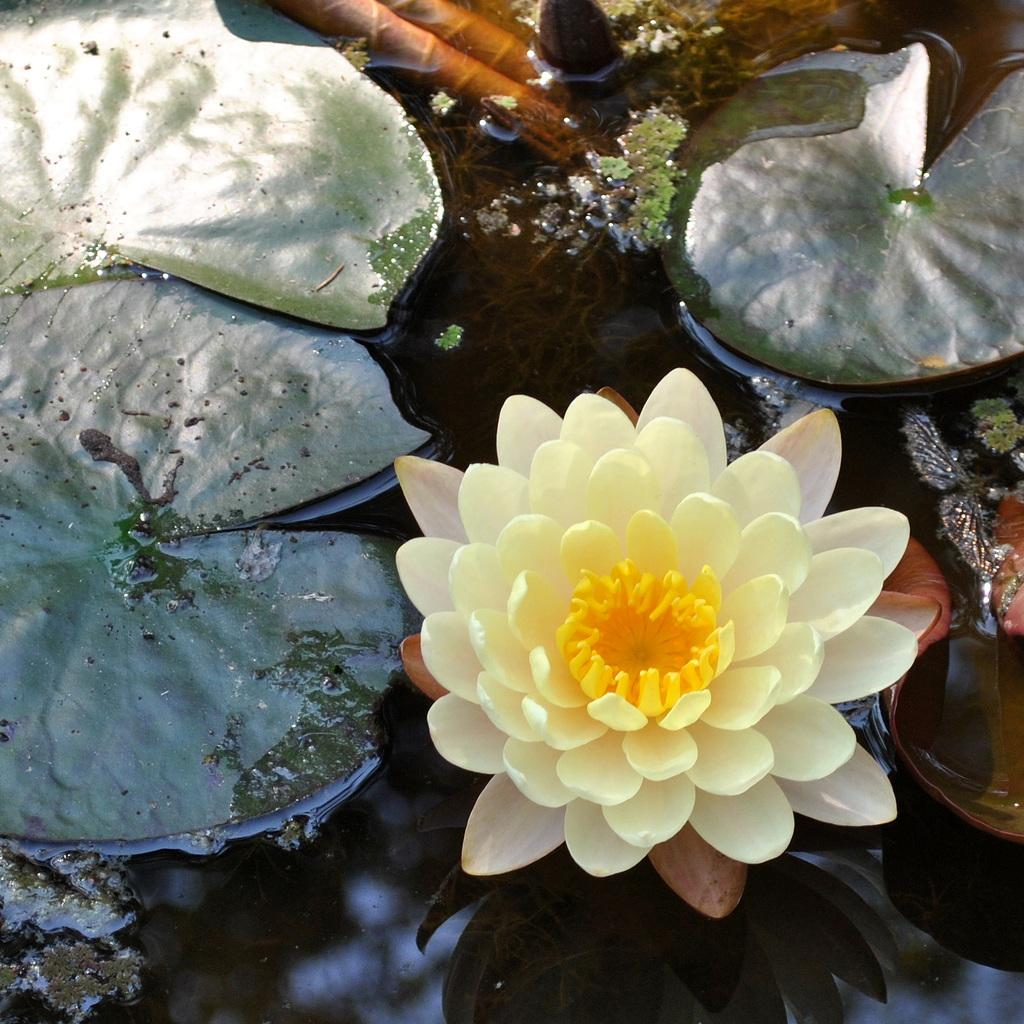What is the flower doing in the image? The flower is in the water in the image. What else can be seen in the water besides the flower? Leaves are present in the image. What type of vegetation is visible in the image? Plants are present in the image. What advice does the flower give to the skate in the image? There is no skate present in the image, and therefore no advice can be given. 